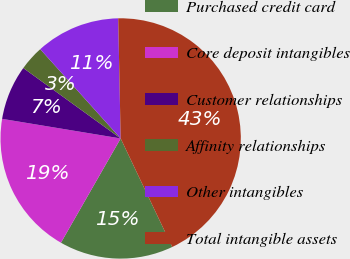Convert chart to OTSL. <chart><loc_0><loc_0><loc_500><loc_500><pie_chart><fcel>Purchased credit card<fcel>Core deposit intangibles<fcel>Customer relationships<fcel>Affinity relationships<fcel>Other intangibles<fcel>Total intangible assets<nl><fcel>15.34%<fcel>19.33%<fcel>7.36%<fcel>3.36%<fcel>11.35%<fcel>43.27%<nl></chart> 